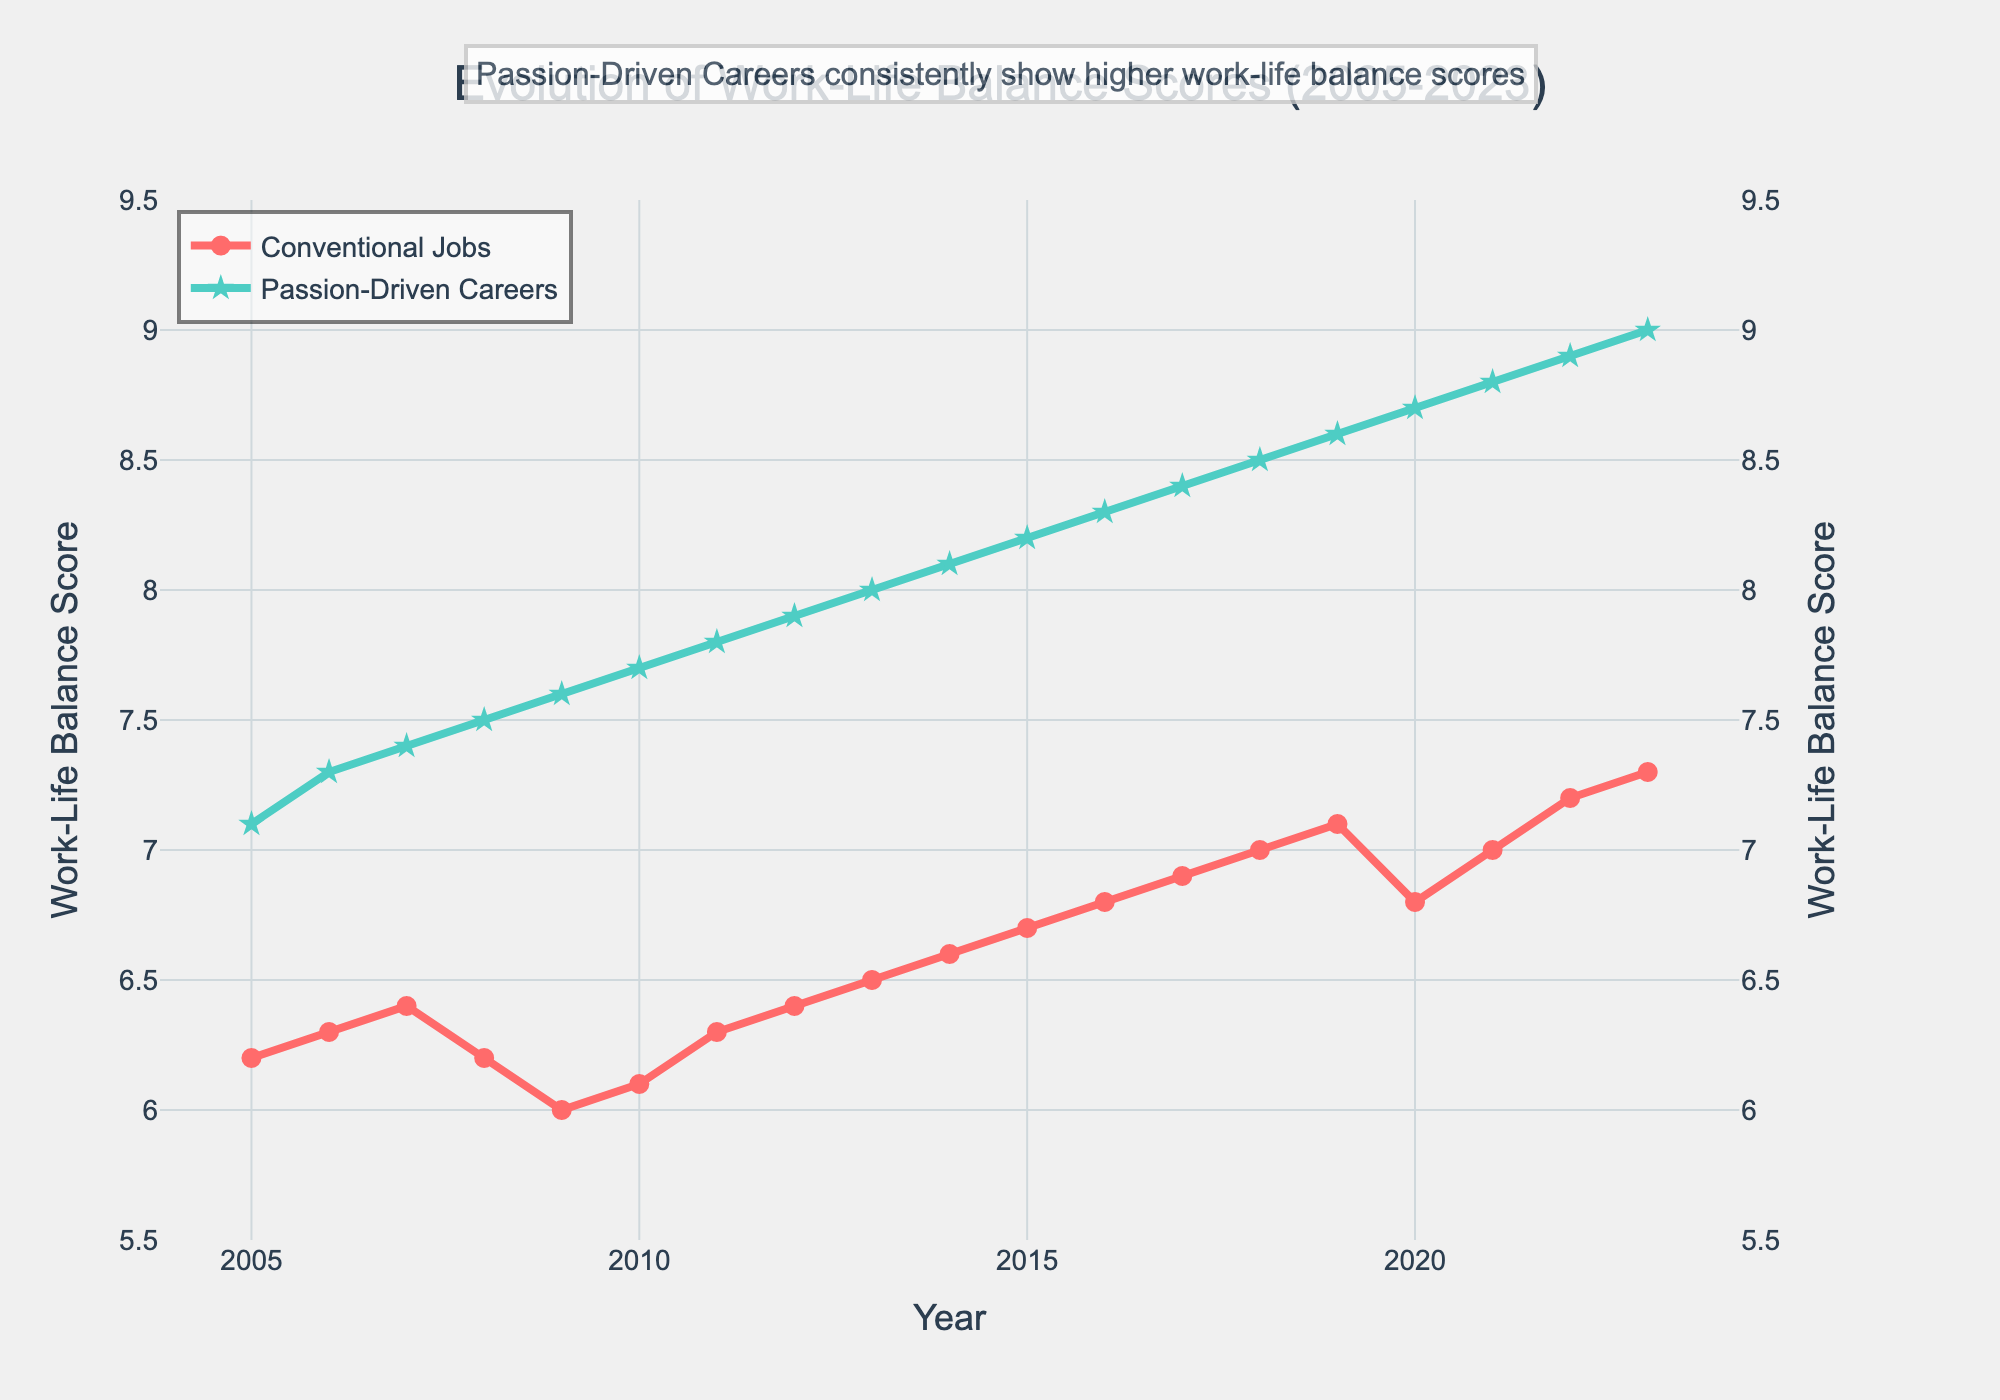What is the work-life balance score for Conventional Jobs in 2010? Refer to the line representing Conventional Jobs and find the data point for the year 2010.
Answer: 6.1 Which year shows the highest work-life balance score for Passion-Driven Careers? Look at the line representing Passion-Driven Careers and identify the highest point, which corresponds to the year 2023.
Answer: 2023 Between 2005 and 2023, in which year did Conventional Jobs experience the sharpest decline in work-life balance score? Examine the trend line for Conventional Jobs and find the largest drop, which occurs between 2019 and 2020.
Answer: Between 2019 and 2020 What is the average work-life balance score of Passion-Driven Careers from 2005 to 2023? Sum all the scores for Passion-Driven Careers from 2005 to 2023 and divide by the number of years (19).
Answer: 8.1 Did Passion-Driven Careers consistently show higher work-life balance scores compared to Conventional Jobs across all years? Compare the lines for Passion-Driven Careers and Conventional Jobs; the green line (Passion-Driven Careers) is always above the red line (Conventional Jobs).
Answer: Yes By how much did the work-life balance score for Conventional Jobs increase from 2005 to 2023? Subtract the score for 2005 (6.2) from the score for 2023 (7.3).
Answer: 1.1 In which year did both Conventional Jobs and Passion-Driven Careers show the same increase in work-life balance score? Identify the year after which both lines have similar upward trends; both have the same 0.2 increase from 2021 to 2022.
Answer: 2022 How much higher was the work-life balance score for Passion-Driven Careers compared to Conventional Jobs in 2017? Subtract the score for Conventional Jobs in 2017 (6.9) from that for Passion-Driven Careers (8.4).
Answer: 1.5 Do the work-life balance scores for both Conventional Jobs and Passion-Driven Careers ever decrease simultaneously? Study the trend lines; only in 2020 do both lines show a dip for that year.
Answer: 2020 